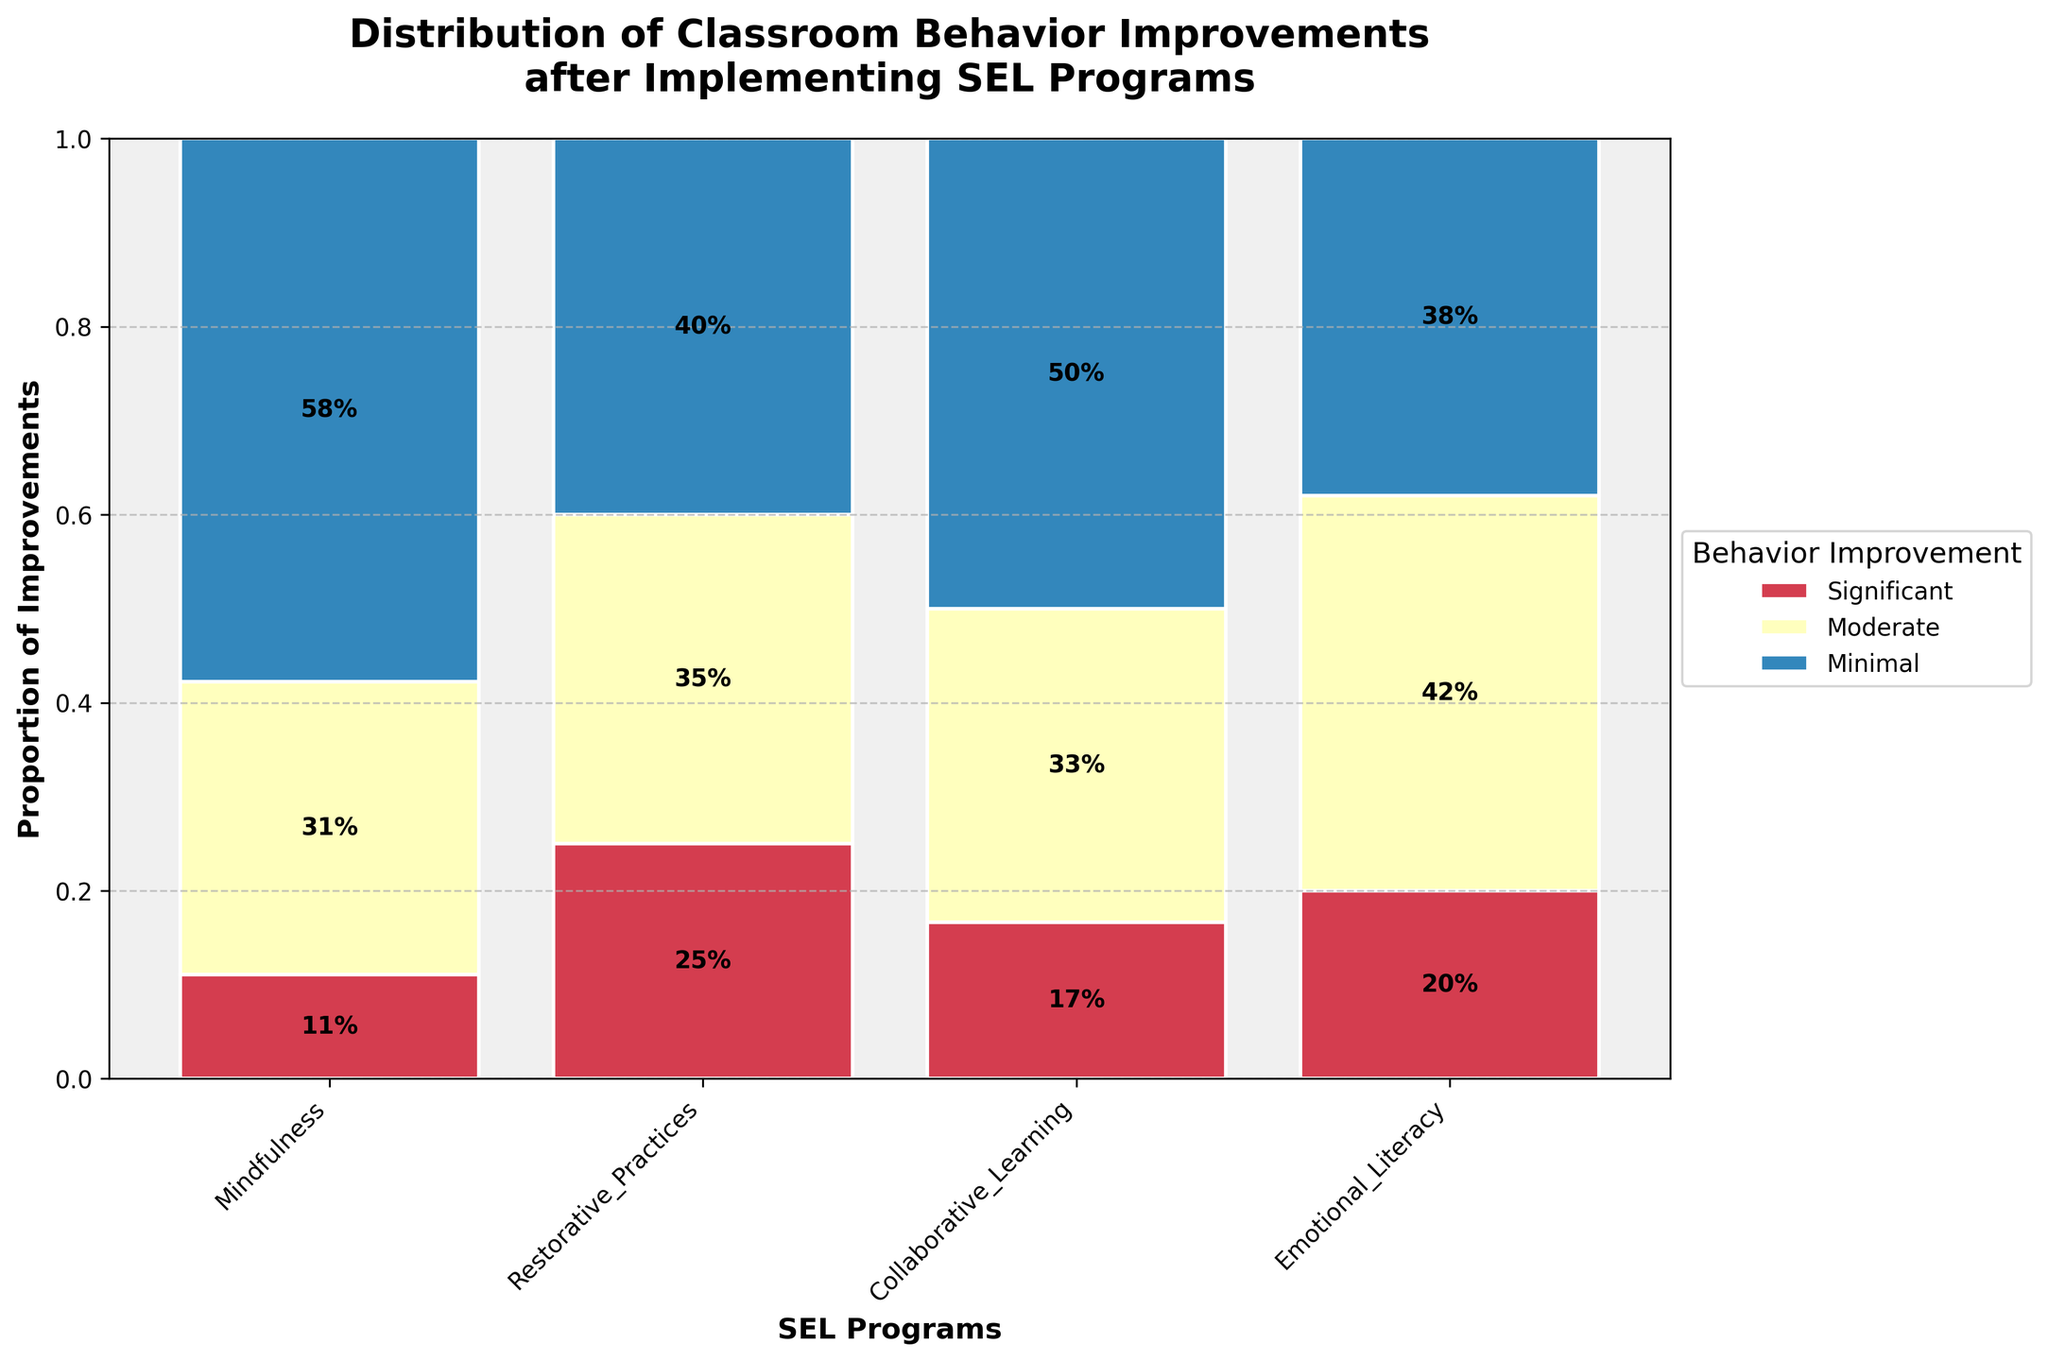What is the title of the figure? The title of the figure is located at the top of the plot, usually in larger and bold text. It gives an overall description of what the plot is about.
Answer: Distribution of Classroom Behavior Improvements after Implementing SEL Programs How many SEL programs are represented in the mosaic plot? Count the number of unique program names listed on the x-axis.
Answer: Four Which SEL program shows the highest proportion of significant behavior improvements? Look at the segment for "Significant" behavior improvement for each SEL program and determine which one reaches the highest on the proportional scale.
Answer: Collaborative Learning Which behavior improvement category has the smallest proportion for the Restorative Practices program? For the "Restorative Practices" program, compare the proportions of each behavior improvement category and identify the smallest one.
Answer: Minimal What is the combined proportion of moderate and minimal behavior improvements for the Emotional Literacy program? Identify the proportions of moderate and minimal behavior improvements for the Emotional Literacy program and sum them up.
Answer: 60% Which SEL program has the smallest total proportion of minimal behavior improvements? Compare the heights of the "Minimal" behavior improvement segments across all SEL programs and find the smallest one.
Answer: Collaborative Learning Between Mindfulness and Emotional Literacy, which program shows a higher proportion of moderate behavior improvements? Compare the heights of the "Moderate" behavior improvement segments for the Mindfulness and Emotional Literacy programs to see which one is higher.
Answer: Restorative Practices Which SEL program has the most balanced distribution across the three categories of behavior improvements? Assess the evenness of the segments for significant, moderate, and minimal behavior improvements for each program; the most balanced will have more equal heights.
Answer: Emotional Literacy By how much does the proportion of significant behavior improvements in Mindfulness exceed minimal behavior improvements in the same program? Subtract the proportion of minimal behavior improvements from significant behavior improvements for the Mindfulness program.
Answer: 50% Which behavior improvement category appears most frequently in significant proportions across the SEL programs? Assess the largest proportions for each behavior improvement category in all SEL programs and identify which category (Significant, Moderate, Minimal) appears most often with the largest proportion.
Answer: Significant 